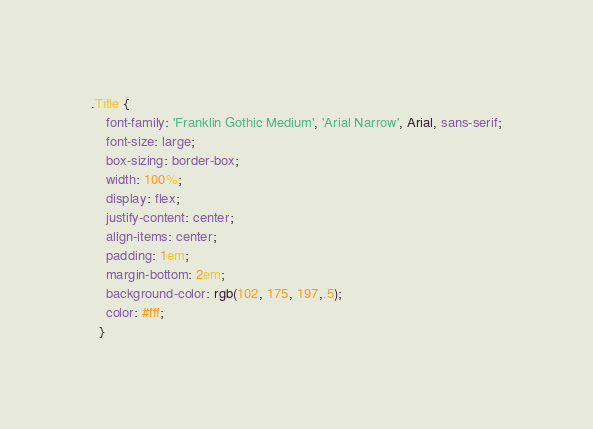Convert code to text. <code><loc_0><loc_0><loc_500><loc_500><_CSS_>.Title {
    font-family: 'Franklin Gothic Medium', 'Arial Narrow', Arial, sans-serif;
    font-size: large;
    box-sizing: border-box;
    width: 100%;
    display: flex;
    justify-content: center;
    align-items: center;
    padding: 1em;
    margin-bottom: 2em;
    background-color: rgb(102, 175, 197,.5);
    color: #fff;
  }</code> 